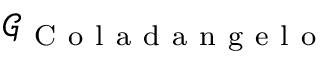<formula> <loc_0><loc_0><loc_500><loc_500>\mathcal { G } _ { C o l a d a n g e l o }</formula> 